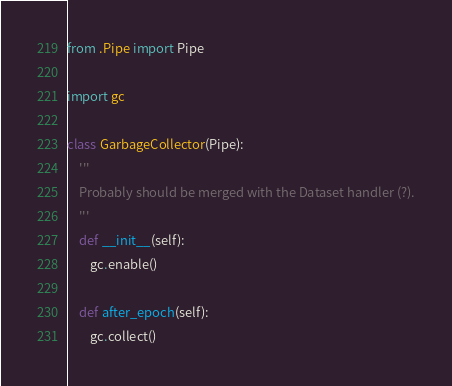Convert code to text. <code><loc_0><loc_0><loc_500><loc_500><_Python_>from .Pipe import Pipe

import gc

class GarbageCollector(Pipe):
    '''
    Probably should be merged with the Dataset handler (?).
    '''
    def __init__(self):
        gc.enable()

    def after_epoch(self):
        gc.collect()</code> 